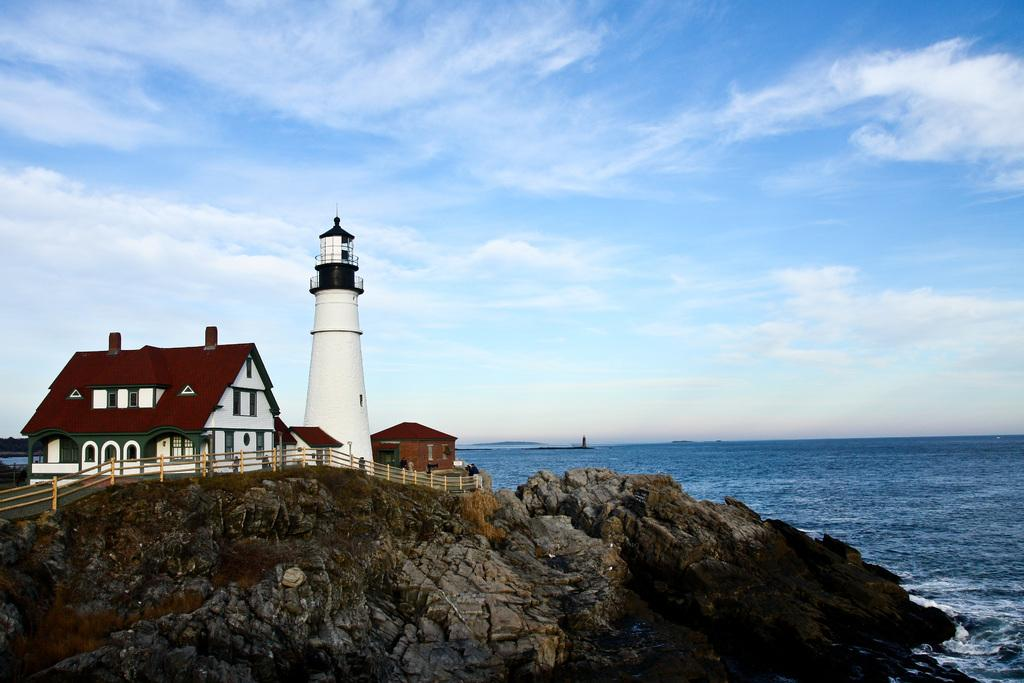What type of structures can be seen in the image? There are houses and a lighthouse in the image. What natural elements are visible in the image? There are rocks and water visible in the image. What man-made feature can be seen in the image? There is a fence in the image. What is visible in the sky in the image? The sky is visible in the image, and clouds are present. What type of pancake is being served at the industry in the image? There is no pancake or industry present in the image. What is the head of the person doing in the image? There are no people or heads visible in the image. 